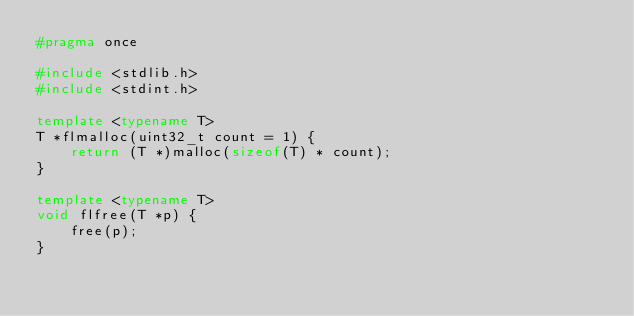<code> <loc_0><loc_0><loc_500><loc_500><_C++_>#pragma once

#include <stdlib.h>
#include <stdint.h>

template <typename T>
T *flmalloc(uint32_t count = 1) {
    return (T *)malloc(sizeof(T) * count);
}

template <typename T>
void flfree(T *p) {
    free(p);
}
</code> 